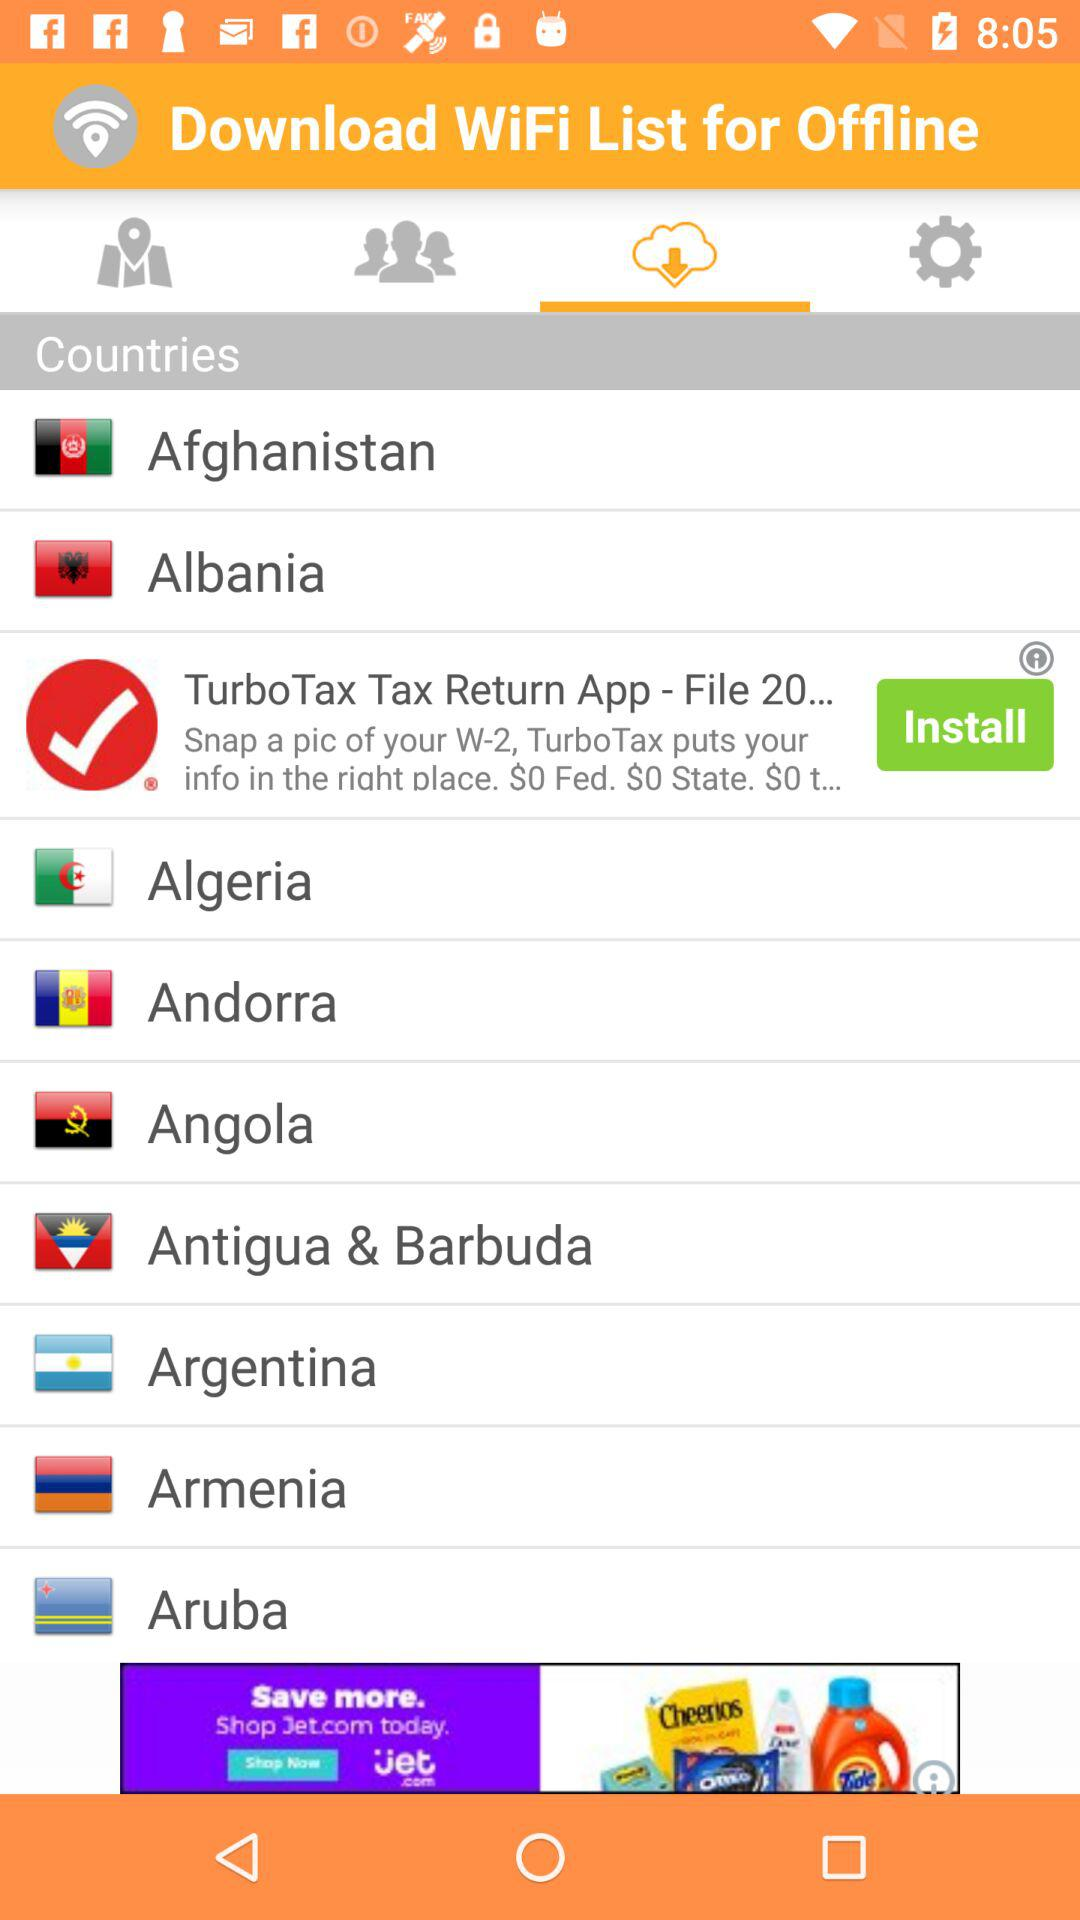Which tab has been selected? The tab that has been selected is "Download from cloud". 